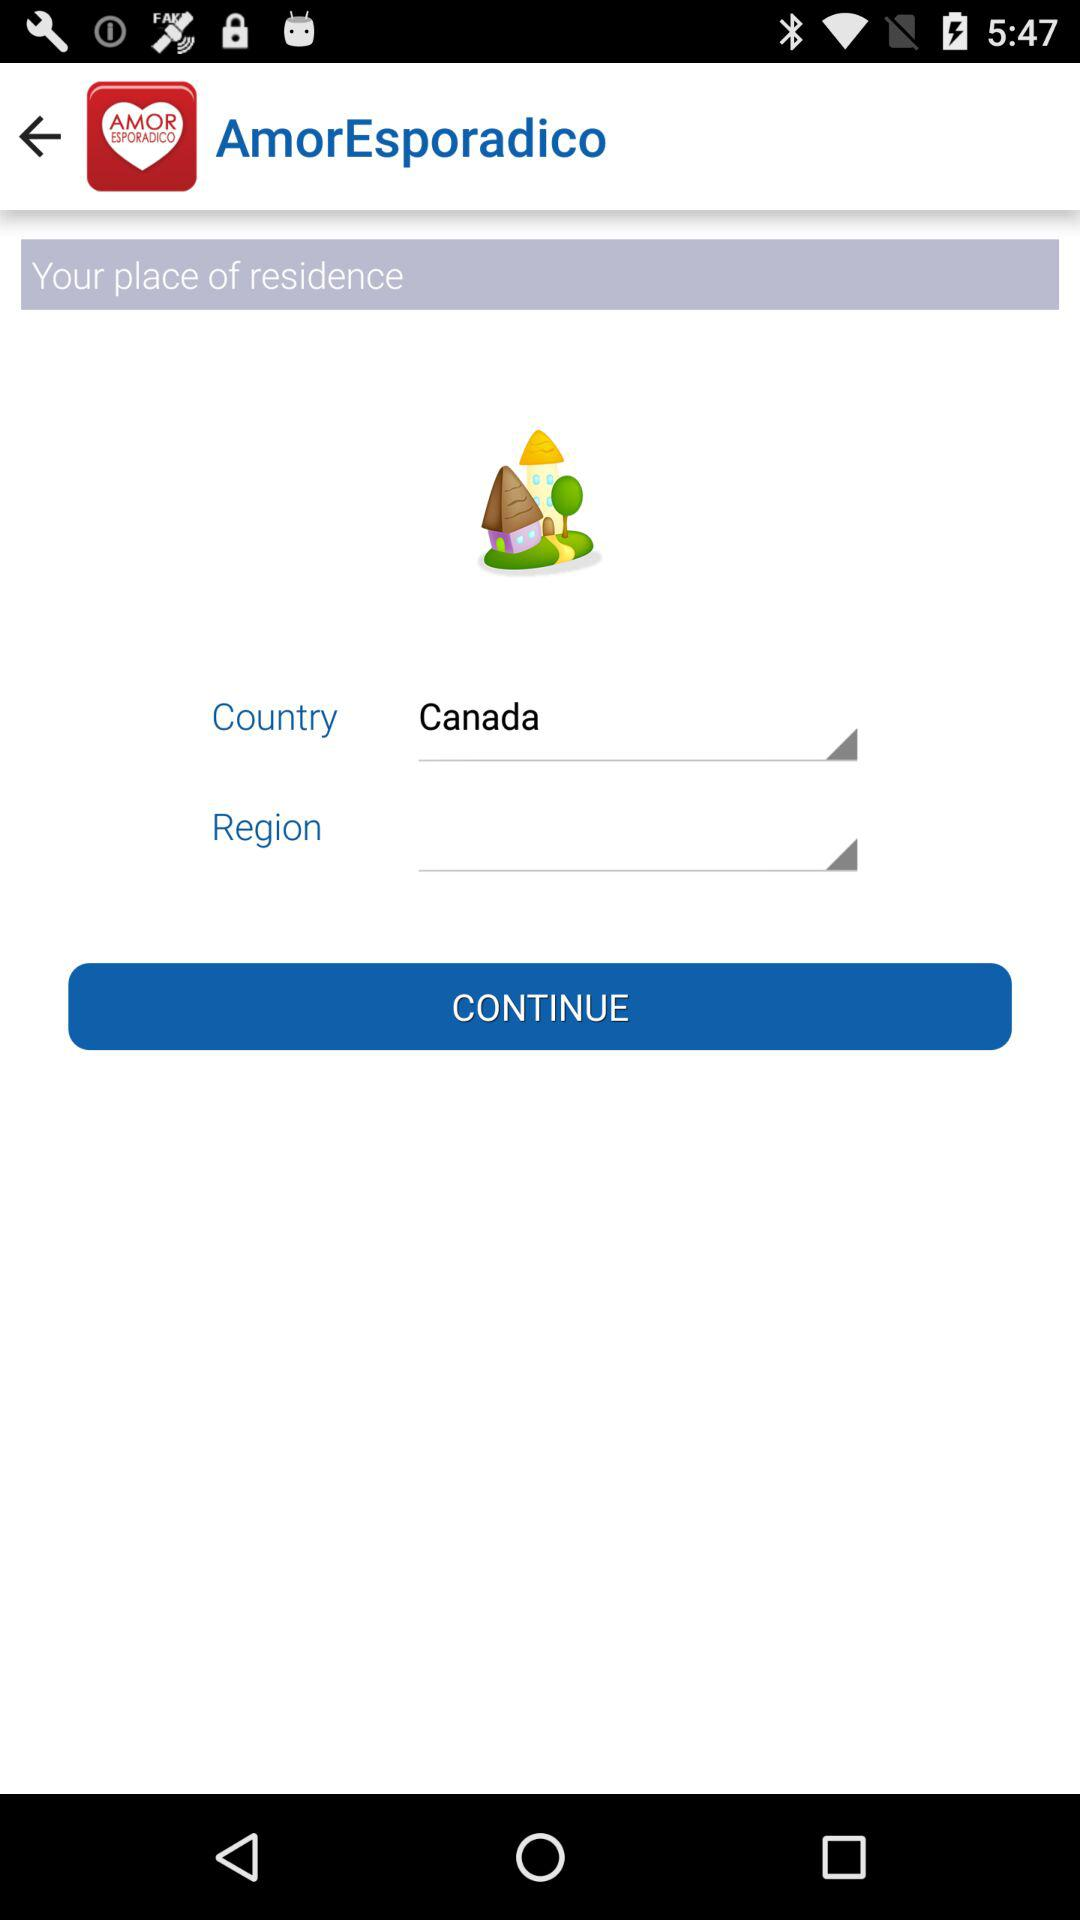What is the application name? The application name is "AmorEsporadico". 